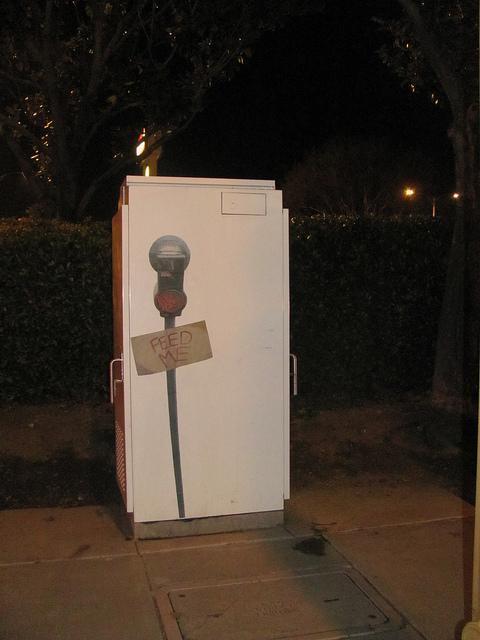How many people are walking under the pink umbreller ?
Give a very brief answer. 0. 